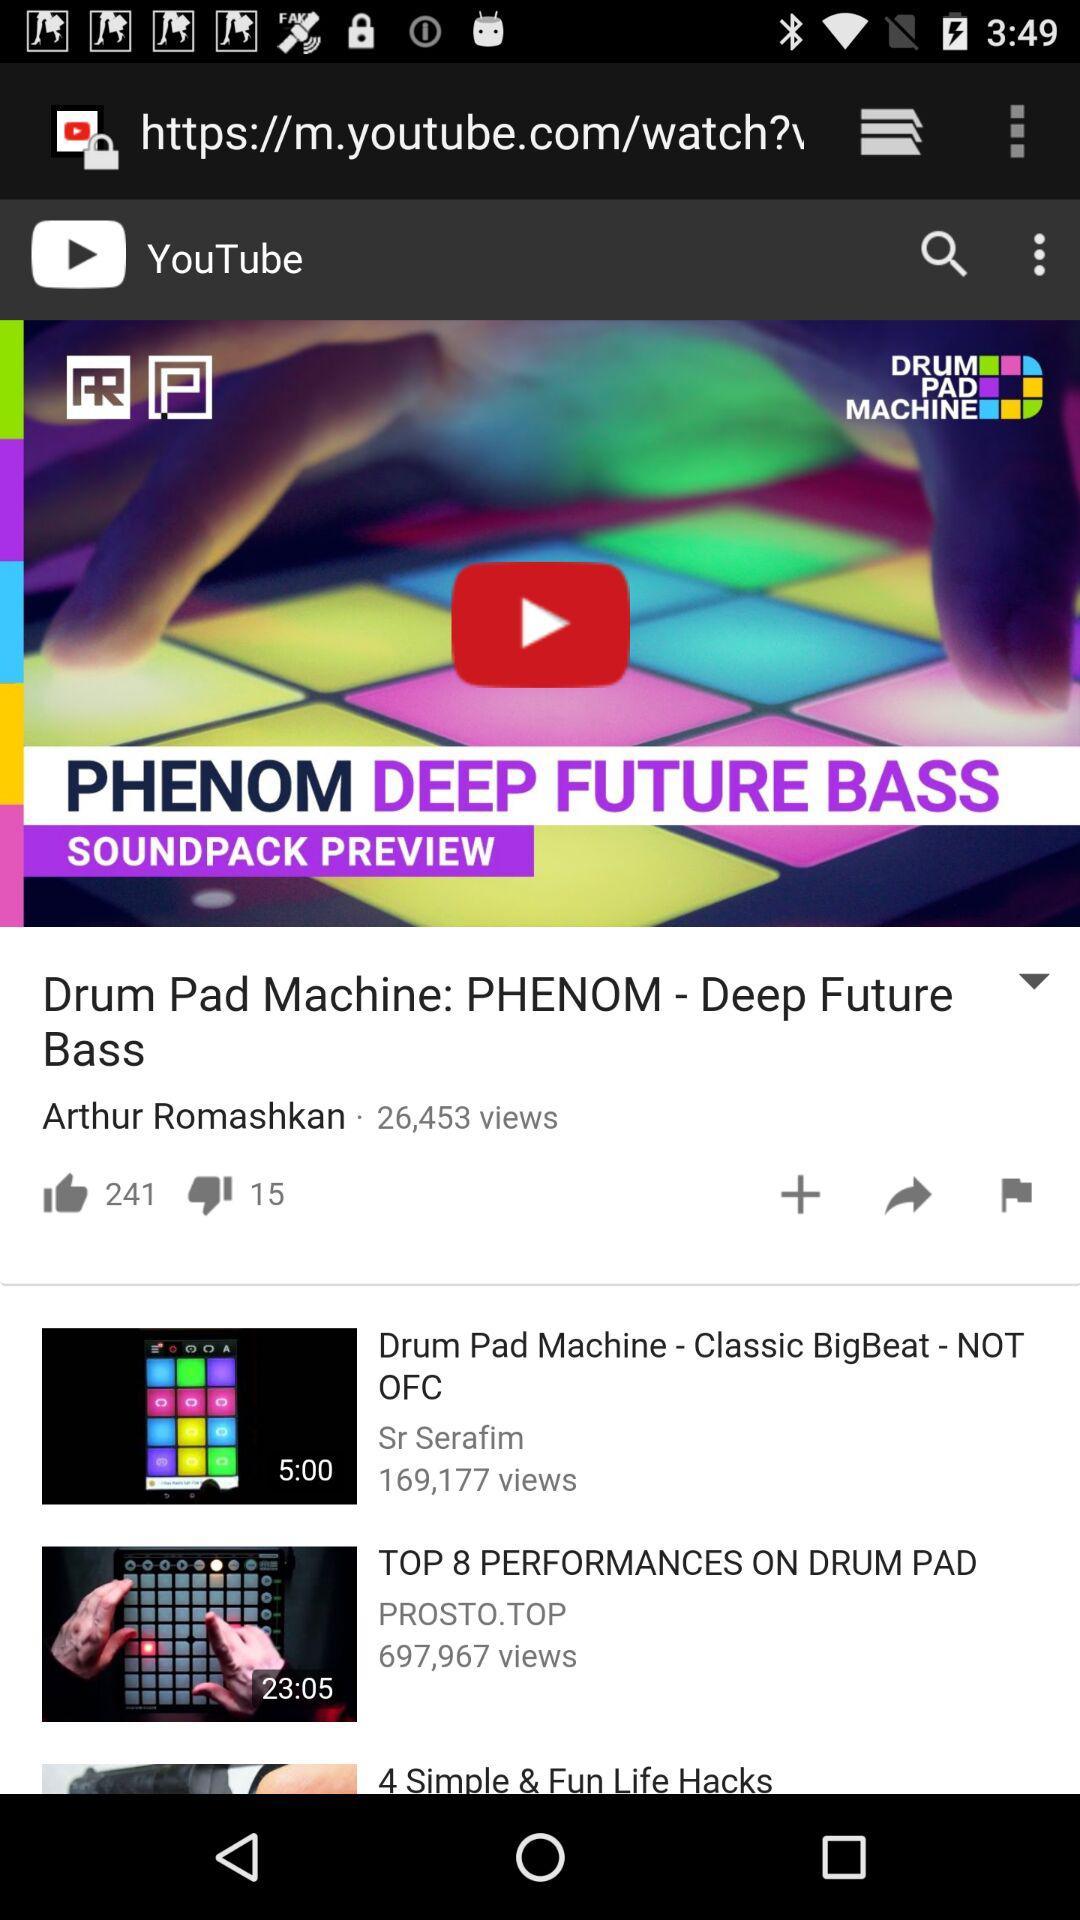What is the duration of "TOP 8 PERFORMANCES ON DRUM PAD"? The duration is 23 minutes and 5 seconds. 